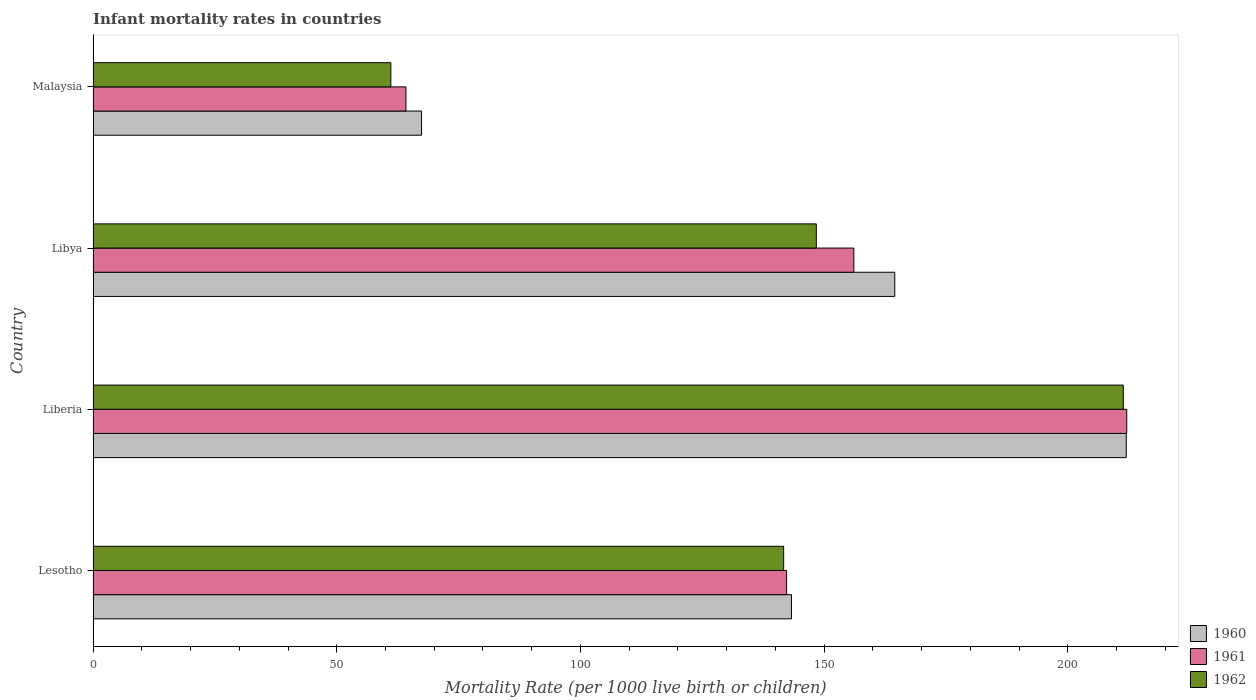Are the number of bars per tick equal to the number of legend labels?
Give a very brief answer. Yes. How many bars are there on the 4th tick from the bottom?
Offer a very short reply. 3. What is the label of the 1st group of bars from the top?
Offer a very short reply. Malaysia. In how many cases, is the number of bars for a given country not equal to the number of legend labels?
Ensure brevity in your answer.  0. What is the infant mortality rate in 1961 in Malaysia?
Your response must be concise. 64.2. Across all countries, what is the maximum infant mortality rate in 1961?
Your answer should be compact. 212.1. Across all countries, what is the minimum infant mortality rate in 1962?
Make the answer very short. 61.1. In which country was the infant mortality rate in 1961 maximum?
Your response must be concise. Liberia. In which country was the infant mortality rate in 1962 minimum?
Provide a succinct answer. Malaysia. What is the total infant mortality rate in 1960 in the graph?
Keep it short and to the point. 587.2. What is the difference between the infant mortality rate in 1960 in Lesotho and that in Malaysia?
Keep it short and to the point. 75.9. What is the difference between the infant mortality rate in 1961 in Lesotho and the infant mortality rate in 1960 in Liberia?
Offer a very short reply. -69.7. What is the average infant mortality rate in 1960 per country?
Ensure brevity in your answer.  146.8. What is the difference between the infant mortality rate in 1962 and infant mortality rate in 1960 in Libya?
Offer a very short reply. -16.1. In how many countries, is the infant mortality rate in 1960 greater than 50 ?
Provide a short and direct response. 4. What is the ratio of the infant mortality rate in 1960 in Liberia to that in Libya?
Give a very brief answer. 1.29. Is the infant mortality rate in 1962 in Liberia less than that in Libya?
Your answer should be compact. No. Is the difference between the infant mortality rate in 1962 in Lesotho and Libya greater than the difference between the infant mortality rate in 1960 in Lesotho and Libya?
Your response must be concise. Yes. What is the difference between the highest and the second highest infant mortality rate in 1960?
Give a very brief answer. 47.5. What is the difference between the highest and the lowest infant mortality rate in 1960?
Ensure brevity in your answer.  144.6. What does the 1st bar from the bottom in Liberia represents?
Your answer should be compact. 1960. Is it the case that in every country, the sum of the infant mortality rate in 1960 and infant mortality rate in 1962 is greater than the infant mortality rate in 1961?
Offer a very short reply. Yes. How many countries are there in the graph?
Ensure brevity in your answer.  4. What is the difference between two consecutive major ticks on the X-axis?
Give a very brief answer. 50. Are the values on the major ticks of X-axis written in scientific E-notation?
Give a very brief answer. No. How are the legend labels stacked?
Keep it short and to the point. Vertical. What is the title of the graph?
Offer a very short reply. Infant mortality rates in countries. What is the label or title of the X-axis?
Your response must be concise. Mortality Rate (per 1000 live birth or children). What is the Mortality Rate (per 1000 live birth or children) of 1960 in Lesotho?
Make the answer very short. 143.3. What is the Mortality Rate (per 1000 live birth or children) in 1961 in Lesotho?
Your answer should be very brief. 142.3. What is the Mortality Rate (per 1000 live birth or children) of 1962 in Lesotho?
Your answer should be very brief. 141.7. What is the Mortality Rate (per 1000 live birth or children) of 1960 in Liberia?
Ensure brevity in your answer.  212. What is the Mortality Rate (per 1000 live birth or children) in 1961 in Liberia?
Provide a short and direct response. 212.1. What is the Mortality Rate (per 1000 live birth or children) in 1962 in Liberia?
Offer a terse response. 211.4. What is the Mortality Rate (per 1000 live birth or children) in 1960 in Libya?
Make the answer very short. 164.5. What is the Mortality Rate (per 1000 live birth or children) in 1961 in Libya?
Keep it short and to the point. 156.1. What is the Mortality Rate (per 1000 live birth or children) of 1962 in Libya?
Keep it short and to the point. 148.4. What is the Mortality Rate (per 1000 live birth or children) of 1960 in Malaysia?
Offer a very short reply. 67.4. What is the Mortality Rate (per 1000 live birth or children) in 1961 in Malaysia?
Offer a terse response. 64.2. What is the Mortality Rate (per 1000 live birth or children) in 1962 in Malaysia?
Ensure brevity in your answer.  61.1. Across all countries, what is the maximum Mortality Rate (per 1000 live birth or children) of 1960?
Keep it short and to the point. 212. Across all countries, what is the maximum Mortality Rate (per 1000 live birth or children) of 1961?
Keep it short and to the point. 212.1. Across all countries, what is the maximum Mortality Rate (per 1000 live birth or children) in 1962?
Your answer should be very brief. 211.4. Across all countries, what is the minimum Mortality Rate (per 1000 live birth or children) of 1960?
Your response must be concise. 67.4. Across all countries, what is the minimum Mortality Rate (per 1000 live birth or children) of 1961?
Give a very brief answer. 64.2. Across all countries, what is the minimum Mortality Rate (per 1000 live birth or children) of 1962?
Ensure brevity in your answer.  61.1. What is the total Mortality Rate (per 1000 live birth or children) in 1960 in the graph?
Your answer should be compact. 587.2. What is the total Mortality Rate (per 1000 live birth or children) of 1961 in the graph?
Provide a short and direct response. 574.7. What is the total Mortality Rate (per 1000 live birth or children) of 1962 in the graph?
Keep it short and to the point. 562.6. What is the difference between the Mortality Rate (per 1000 live birth or children) in 1960 in Lesotho and that in Liberia?
Provide a short and direct response. -68.7. What is the difference between the Mortality Rate (per 1000 live birth or children) in 1961 in Lesotho and that in Liberia?
Ensure brevity in your answer.  -69.8. What is the difference between the Mortality Rate (per 1000 live birth or children) in 1962 in Lesotho and that in Liberia?
Make the answer very short. -69.7. What is the difference between the Mortality Rate (per 1000 live birth or children) in 1960 in Lesotho and that in Libya?
Your answer should be compact. -21.2. What is the difference between the Mortality Rate (per 1000 live birth or children) in 1961 in Lesotho and that in Libya?
Provide a short and direct response. -13.8. What is the difference between the Mortality Rate (per 1000 live birth or children) in 1960 in Lesotho and that in Malaysia?
Give a very brief answer. 75.9. What is the difference between the Mortality Rate (per 1000 live birth or children) in 1961 in Lesotho and that in Malaysia?
Your answer should be compact. 78.1. What is the difference between the Mortality Rate (per 1000 live birth or children) in 1962 in Lesotho and that in Malaysia?
Make the answer very short. 80.6. What is the difference between the Mortality Rate (per 1000 live birth or children) in 1960 in Liberia and that in Libya?
Give a very brief answer. 47.5. What is the difference between the Mortality Rate (per 1000 live birth or children) of 1961 in Liberia and that in Libya?
Your answer should be very brief. 56. What is the difference between the Mortality Rate (per 1000 live birth or children) in 1962 in Liberia and that in Libya?
Offer a terse response. 63. What is the difference between the Mortality Rate (per 1000 live birth or children) of 1960 in Liberia and that in Malaysia?
Keep it short and to the point. 144.6. What is the difference between the Mortality Rate (per 1000 live birth or children) of 1961 in Liberia and that in Malaysia?
Give a very brief answer. 147.9. What is the difference between the Mortality Rate (per 1000 live birth or children) of 1962 in Liberia and that in Malaysia?
Ensure brevity in your answer.  150.3. What is the difference between the Mortality Rate (per 1000 live birth or children) in 1960 in Libya and that in Malaysia?
Provide a short and direct response. 97.1. What is the difference between the Mortality Rate (per 1000 live birth or children) of 1961 in Libya and that in Malaysia?
Make the answer very short. 91.9. What is the difference between the Mortality Rate (per 1000 live birth or children) in 1962 in Libya and that in Malaysia?
Offer a very short reply. 87.3. What is the difference between the Mortality Rate (per 1000 live birth or children) in 1960 in Lesotho and the Mortality Rate (per 1000 live birth or children) in 1961 in Liberia?
Offer a very short reply. -68.8. What is the difference between the Mortality Rate (per 1000 live birth or children) of 1960 in Lesotho and the Mortality Rate (per 1000 live birth or children) of 1962 in Liberia?
Make the answer very short. -68.1. What is the difference between the Mortality Rate (per 1000 live birth or children) in 1961 in Lesotho and the Mortality Rate (per 1000 live birth or children) in 1962 in Liberia?
Your answer should be compact. -69.1. What is the difference between the Mortality Rate (per 1000 live birth or children) of 1960 in Lesotho and the Mortality Rate (per 1000 live birth or children) of 1961 in Libya?
Your response must be concise. -12.8. What is the difference between the Mortality Rate (per 1000 live birth or children) in 1960 in Lesotho and the Mortality Rate (per 1000 live birth or children) in 1962 in Libya?
Your answer should be compact. -5.1. What is the difference between the Mortality Rate (per 1000 live birth or children) in 1960 in Lesotho and the Mortality Rate (per 1000 live birth or children) in 1961 in Malaysia?
Provide a short and direct response. 79.1. What is the difference between the Mortality Rate (per 1000 live birth or children) of 1960 in Lesotho and the Mortality Rate (per 1000 live birth or children) of 1962 in Malaysia?
Make the answer very short. 82.2. What is the difference between the Mortality Rate (per 1000 live birth or children) of 1961 in Lesotho and the Mortality Rate (per 1000 live birth or children) of 1962 in Malaysia?
Provide a succinct answer. 81.2. What is the difference between the Mortality Rate (per 1000 live birth or children) of 1960 in Liberia and the Mortality Rate (per 1000 live birth or children) of 1961 in Libya?
Ensure brevity in your answer.  55.9. What is the difference between the Mortality Rate (per 1000 live birth or children) of 1960 in Liberia and the Mortality Rate (per 1000 live birth or children) of 1962 in Libya?
Give a very brief answer. 63.6. What is the difference between the Mortality Rate (per 1000 live birth or children) of 1961 in Liberia and the Mortality Rate (per 1000 live birth or children) of 1962 in Libya?
Give a very brief answer. 63.7. What is the difference between the Mortality Rate (per 1000 live birth or children) in 1960 in Liberia and the Mortality Rate (per 1000 live birth or children) in 1961 in Malaysia?
Provide a short and direct response. 147.8. What is the difference between the Mortality Rate (per 1000 live birth or children) of 1960 in Liberia and the Mortality Rate (per 1000 live birth or children) of 1962 in Malaysia?
Your answer should be very brief. 150.9. What is the difference between the Mortality Rate (per 1000 live birth or children) in 1961 in Liberia and the Mortality Rate (per 1000 live birth or children) in 1962 in Malaysia?
Your response must be concise. 151. What is the difference between the Mortality Rate (per 1000 live birth or children) in 1960 in Libya and the Mortality Rate (per 1000 live birth or children) in 1961 in Malaysia?
Offer a very short reply. 100.3. What is the difference between the Mortality Rate (per 1000 live birth or children) of 1960 in Libya and the Mortality Rate (per 1000 live birth or children) of 1962 in Malaysia?
Offer a terse response. 103.4. What is the average Mortality Rate (per 1000 live birth or children) of 1960 per country?
Your answer should be compact. 146.8. What is the average Mortality Rate (per 1000 live birth or children) of 1961 per country?
Provide a short and direct response. 143.68. What is the average Mortality Rate (per 1000 live birth or children) of 1962 per country?
Offer a terse response. 140.65. What is the difference between the Mortality Rate (per 1000 live birth or children) in 1960 and Mortality Rate (per 1000 live birth or children) in 1962 in Libya?
Your answer should be very brief. 16.1. What is the difference between the Mortality Rate (per 1000 live birth or children) in 1961 and Mortality Rate (per 1000 live birth or children) in 1962 in Libya?
Your answer should be compact. 7.7. What is the difference between the Mortality Rate (per 1000 live birth or children) of 1961 and Mortality Rate (per 1000 live birth or children) of 1962 in Malaysia?
Keep it short and to the point. 3.1. What is the ratio of the Mortality Rate (per 1000 live birth or children) of 1960 in Lesotho to that in Liberia?
Provide a short and direct response. 0.68. What is the ratio of the Mortality Rate (per 1000 live birth or children) in 1961 in Lesotho to that in Liberia?
Make the answer very short. 0.67. What is the ratio of the Mortality Rate (per 1000 live birth or children) in 1962 in Lesotho to that in Liberia?
Ensure brevity in your answer.  0.67. What is the ratio of the Mortality Rate (per 1000 live birth or children) of 1960 in Lesotho to that in Libya?
Provide a short and direct response. 0.87. What is the ratio of the Mortality Rate (per 1000 live birth or children) of 1961 in Lesotho to that in Libya?
Your answer should be very brief. 0.91. What is the ratio of the Mortality Rate (per 1000 live birth or children) in 1962 in Lesotho to that in Libya?
Your answer should be compact. 0.95. What is the ratio of the Mortality Rate (per 1000 live birth or children) of 1960 in Lesotho to that in Malaysia?
Provide a short and direct response. 2.13. What is the ratio of the Mortality Rate (per 1000 live birth or children) in 1961 in Lesotho to that in Malaysia?
Provide a short and direct response. 2.22. What is the ratio of the Mortality Rate (per 1000 live birth or children) of 1962 in Lesotho to that in Malaysia?
Your answer should be compact. 2.32. What is the ratio of the Mortality Rate (per 1000 live birth or children) in 1960 in Liberia to that in Libya?
Your answer should be compact. 1.29. What is the ratio of the Mortality Rate (per 1000 live birth or children) in 1961 in Liberia to that in Libya?
Give a very brief answer. 1.36. What is the ratio of the Mortality Rate (per 1000 live birth or children) of 1962 in Liberia to that in Libya?
Offer a very short reply. 1.42. What is the ratio of the Mortality Rate (per 1000 live birth or children) in 1960 in Liberia to that in Malaysia?
Keep it short and to the point. 3.15. What is the ratio of the Mortality Rate (per 1000 live birth or children) of 1961 in Liberia to that in Malaysia?
Make the answer very short. 3.3. What is the ratio of the Mortality Rate (per 1000 live birth or children) in 1962 in Liberia to that in Malaysia?
Provide a succinct answer. 3.46. What is the ratio of the Mortality Rate (per 1000 live birth or children) of 1960 in Libya to that in Malaysia?
Your answer should be very brief. 2.44. What is the ratio of the Mortality Rate (per 1000 live birth or children) in 1961 in Libya to that in Malaysia?
Give a very brief answer. 2.43. What is the ratio of the Mortality Rate (per 1000 live birth or children) in 1962 in Libya to that in Malaysia?
Ensure brevity in your answer.  2.43. What is the difference between the highest and the second highest Mortality Rate (per 1000 live birth or children) of 1960?
Your answer should be very brief. 47.5. What is the difference between the highest and the second highest Mortality Rate (per 1000 live birth or children) of 1961?
Your answer should be very brief. 56. What is the difference between the highest and the lowest Mortality Rate (per 1000 live birth or children) in 1960?
Keep it short and to the point. 144.6. What is the difference between the highest and the lowest Mortality Rate (per 1000 live birth or children) of 1961?
Your response must be concise. 147.9. What is the difference between the highest and the lowest Mortality Rate (per 1000 live birth or children) in 1962?
Offer a terse response. 150.3. 